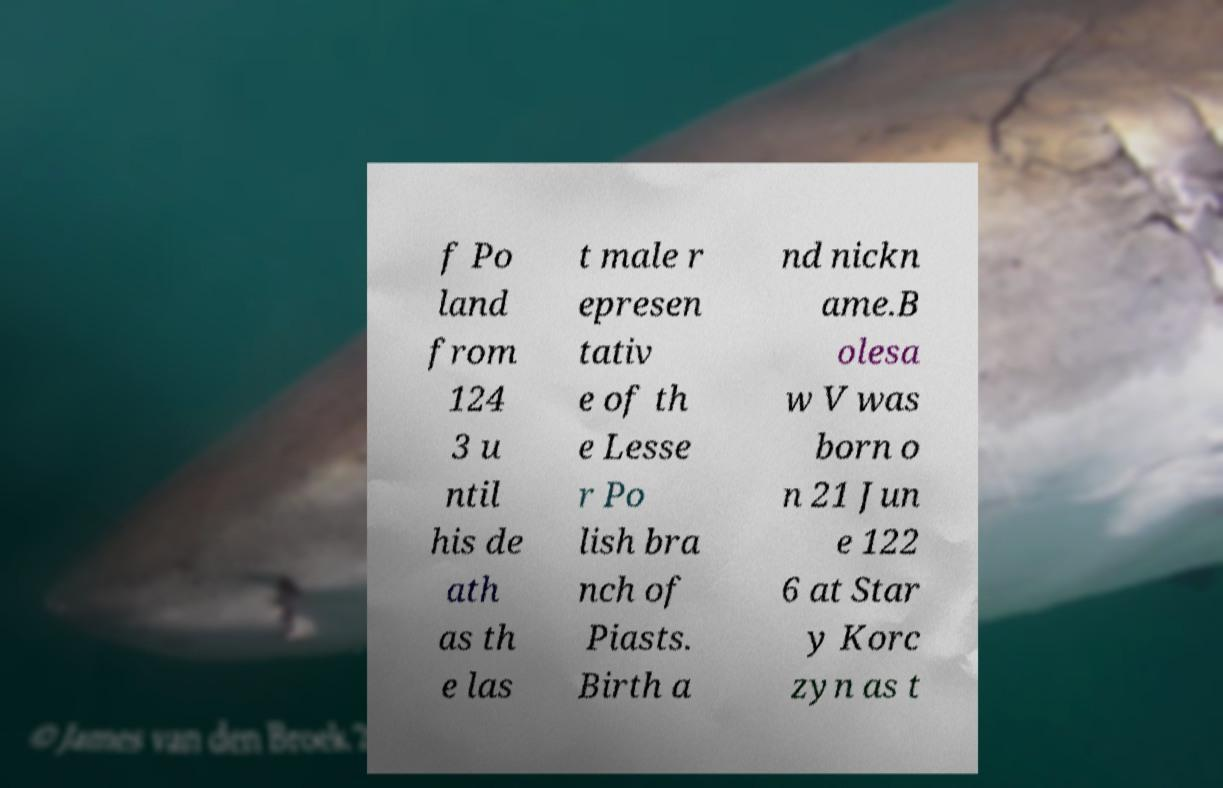For documentation purposes, I need the text within this image transcribed. Could you provide that? f Po land from 124 3 u ntil his de ath as th e las t male r epresen tativ e of th e Lesse r Po lish bra nch of Piasts. Birth a nd nickn ame.B olesa w V was born o n 21 Jun e 122 6 at Star y Korc zyn as t 